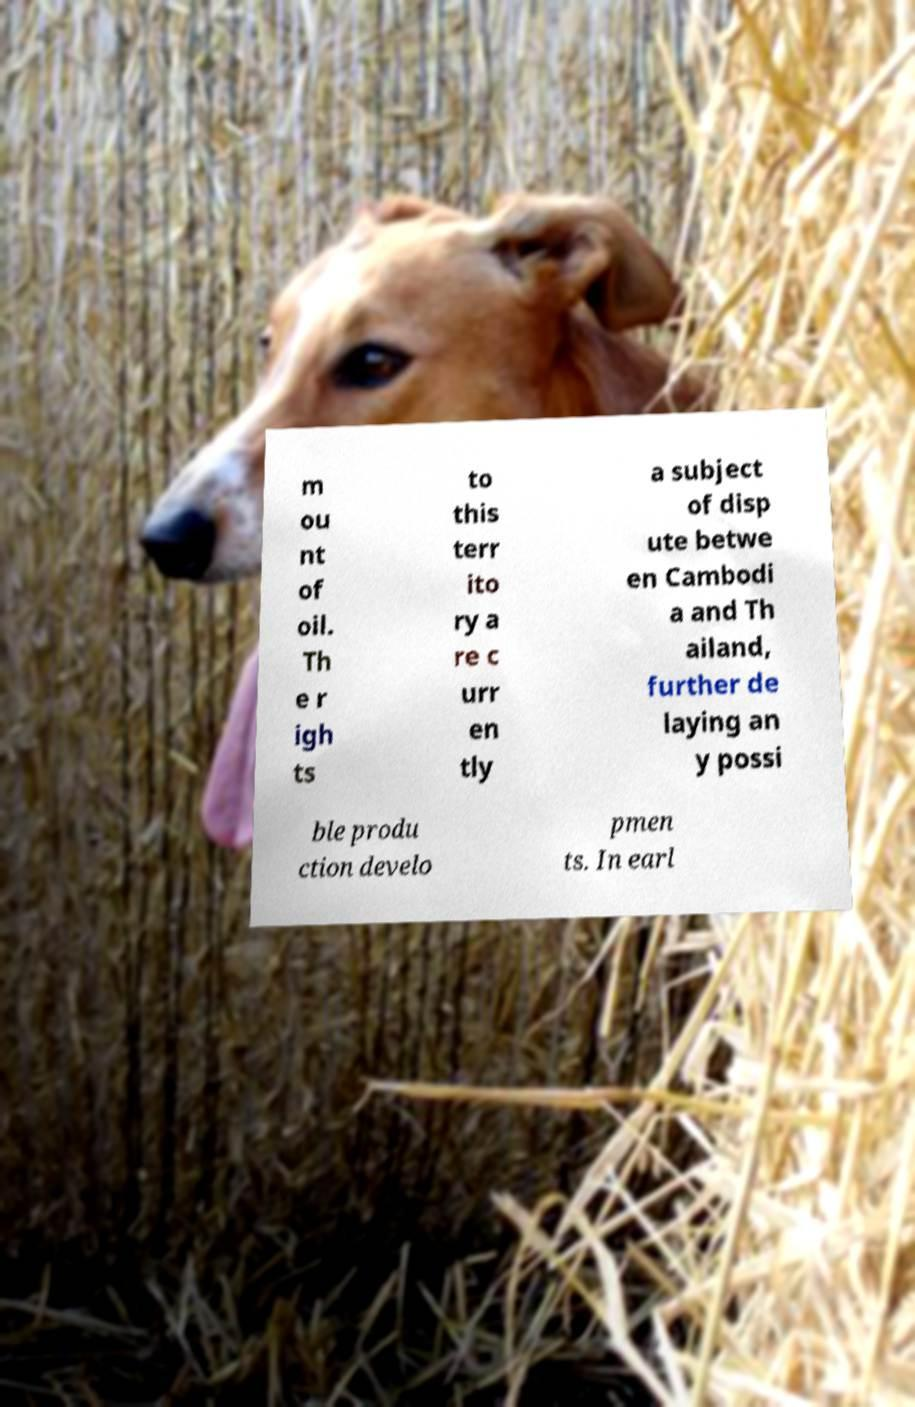I need the written content from this picture converted into text. Can you do that? m ou nt of oil. Th e r igh ts to this terr ito ry a re c urr en tly a subject of disp ute betwe en Cambodi a and Th ailand, further de laying an y possi ble produ ction develo pmen ts. In earl 